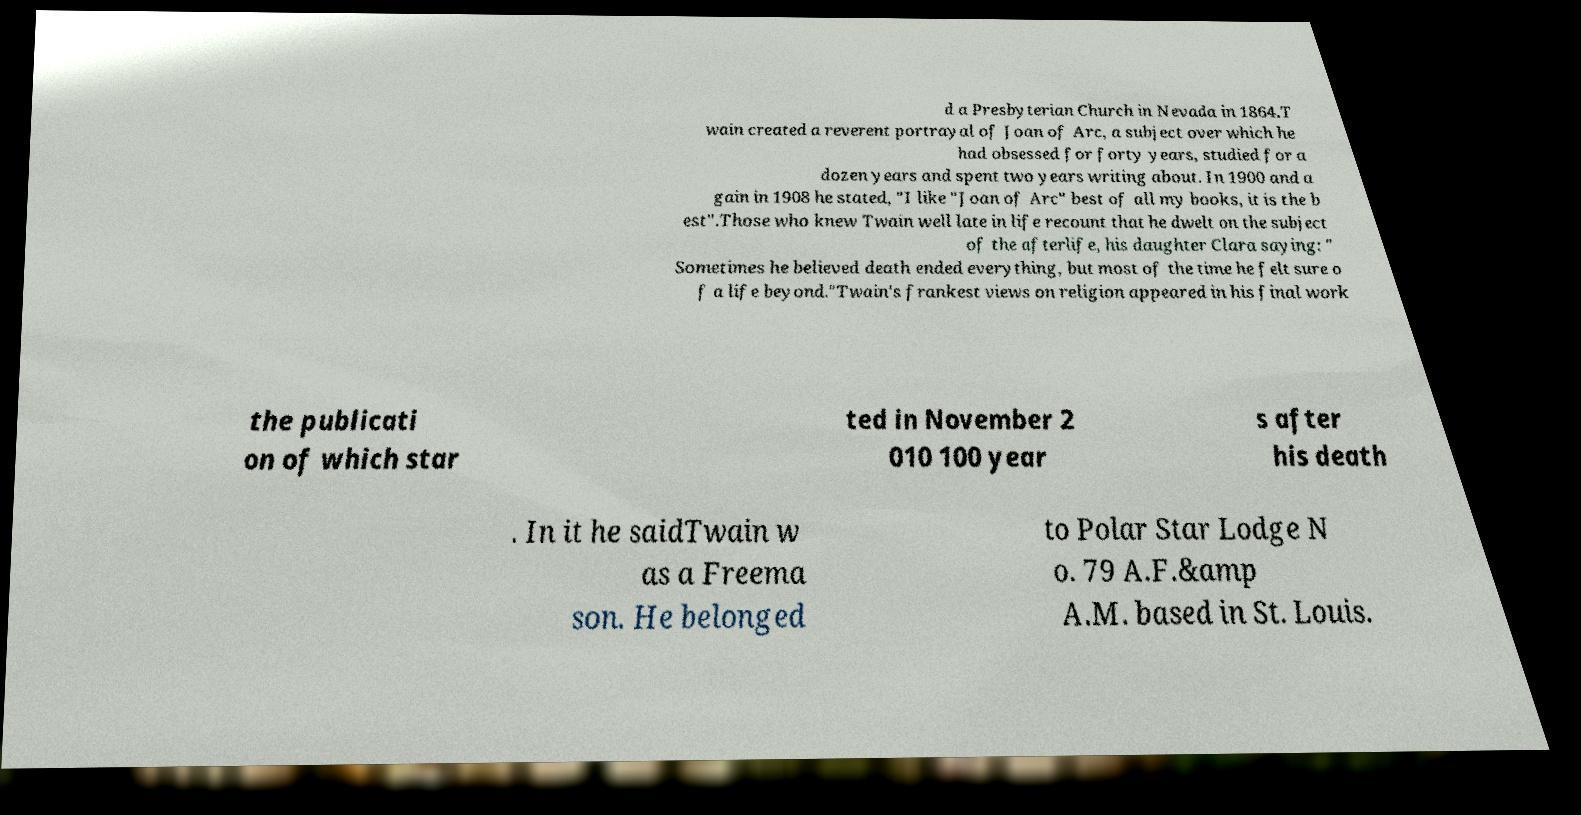Please identify and transcribe the text found in this image. d a Presbyterian Church in Nevada in 1864.T wain created a reverent portrayal of Joan of Arc, a subject over which he had obsessed for forty years, studied for a dozen years and spent two years writing about. In 1900 and a gain in 1908 he stated, "I like "Joan of Arc" best of all my books, it is the b est".Those who knew Twain well late in life recount that he dwelt on the subject of the afterlife, his daughter Clara saying: " Sometimes he believed death ended everything, but most of the time he felt sure o f a life beyond."Twain's frankest views on religion appeared in his final work the publicati on of which star ted in November 2 010 100 year s after his death . In it he saidTwain w as a Freema son. He belonged to Polar Star Lodge N o. 79 A.F.&amp A.M. based in St. Louis. 